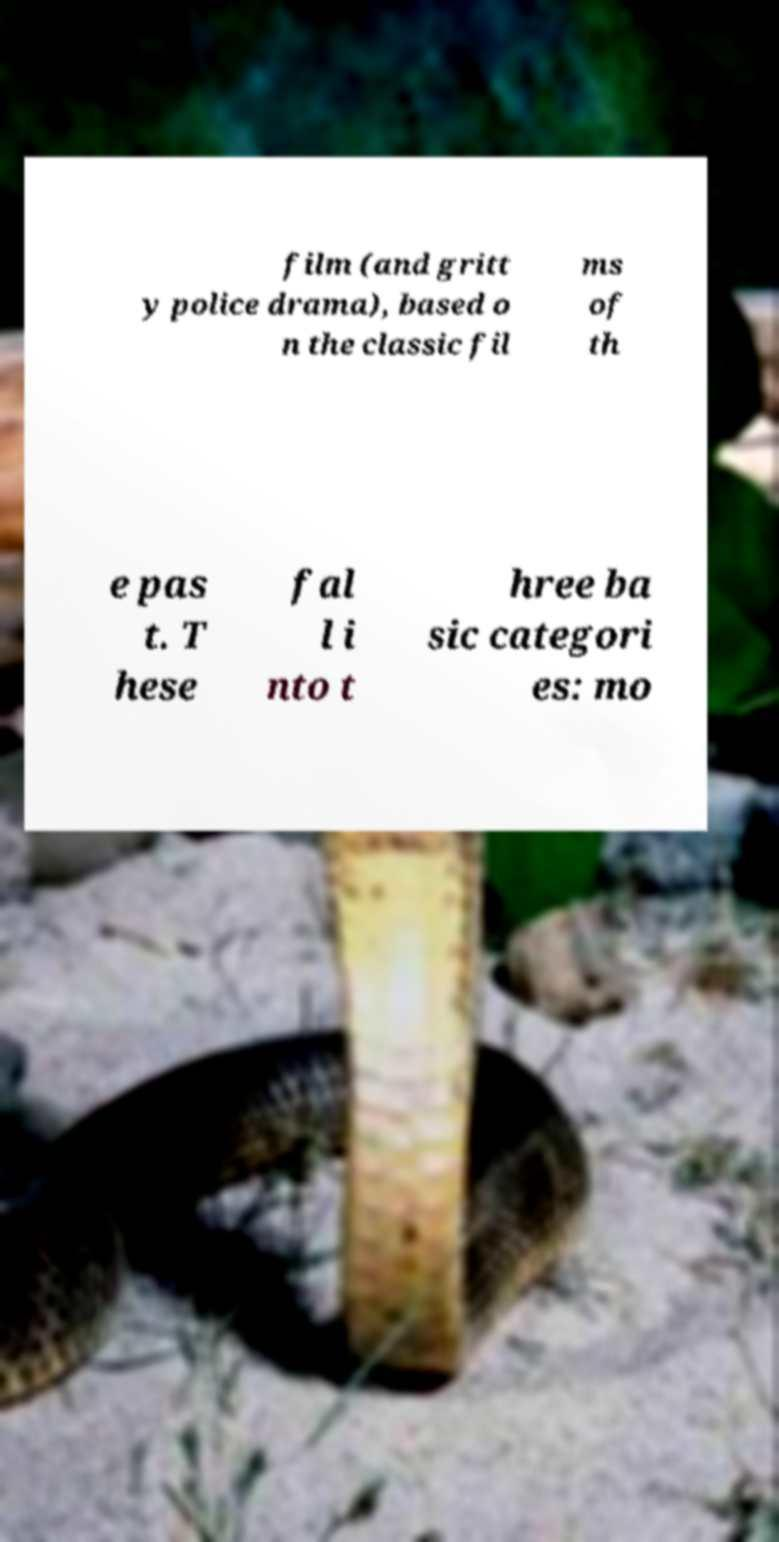Please read and relay the text visible in this image. What does it say? film (and gritt y police drama), based o n the classic fil ms of th e pas t. T hese fal l i nto t hree ba sic categori es: mo 